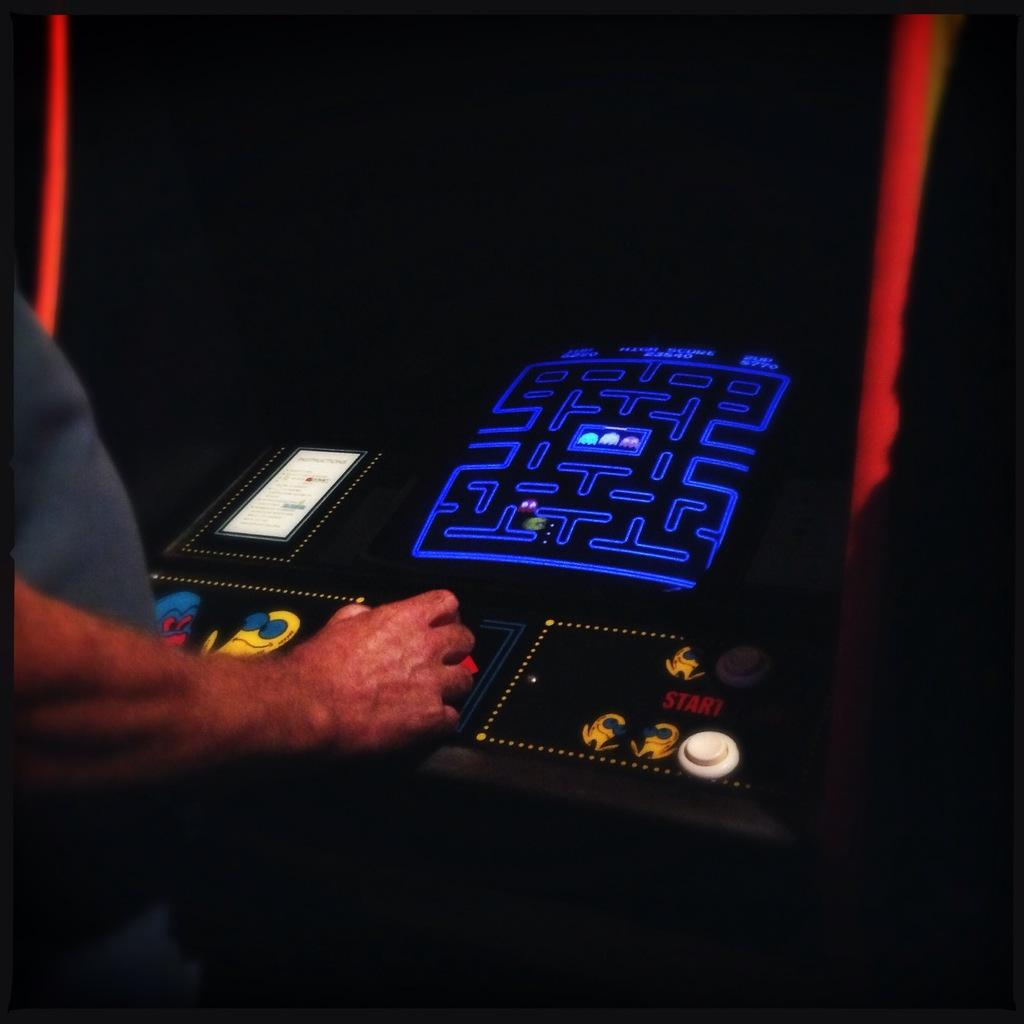Who is present in the image? There is a person in the image. What is the person wearing? The person is wearing a grey dress. What is the person standing in front of? The person is standing in front of a gaming machine. What colors can be seen on the gaming machine? The gaming machine is black, blue, white, and yellow in color. What type of scarf is the person wearing in the image? The person is not wearing a scarf in the image. Can you tell me what brand of soda is being advertised on the gaming machine? There is no soda or advertisement visible on the gaming machine in the image. 